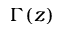Convert formula to latex. <formula><loc_0><loc_0><loc_500><loc_500>\Gamma ( z )</formula> 